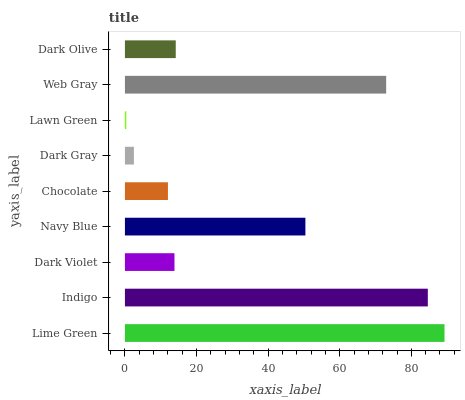Is Lawn Green the minimum?
Answer yes or no. Yes. Is Lime Green the maximum?
Answer yes or no. Yes. Is Indigo the minimum?
Answer yes or no. No. Is Indigo the maximum?
Answer yes or no. No. Is Lime Green greater than Indigo?
Answer yes or no. Yes. Is Indigo less than Lime Green?
Answer yes or no. Yes. Is Indigo greater than Lime Green?
Answer yes or no. No. Is Lime Green less than Indigo?
Answer yes or no. No. Is Dark Olive the high median?
Answer yes or no. Yes. Is Dark Olive the low median?
Answer yes or no. Yes. Is Dark Violet the high median?
Answer yes or no. No. Is Dark Violet the low median?
Answer yes or no. No. 